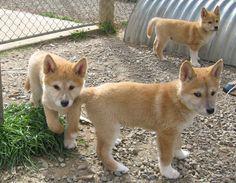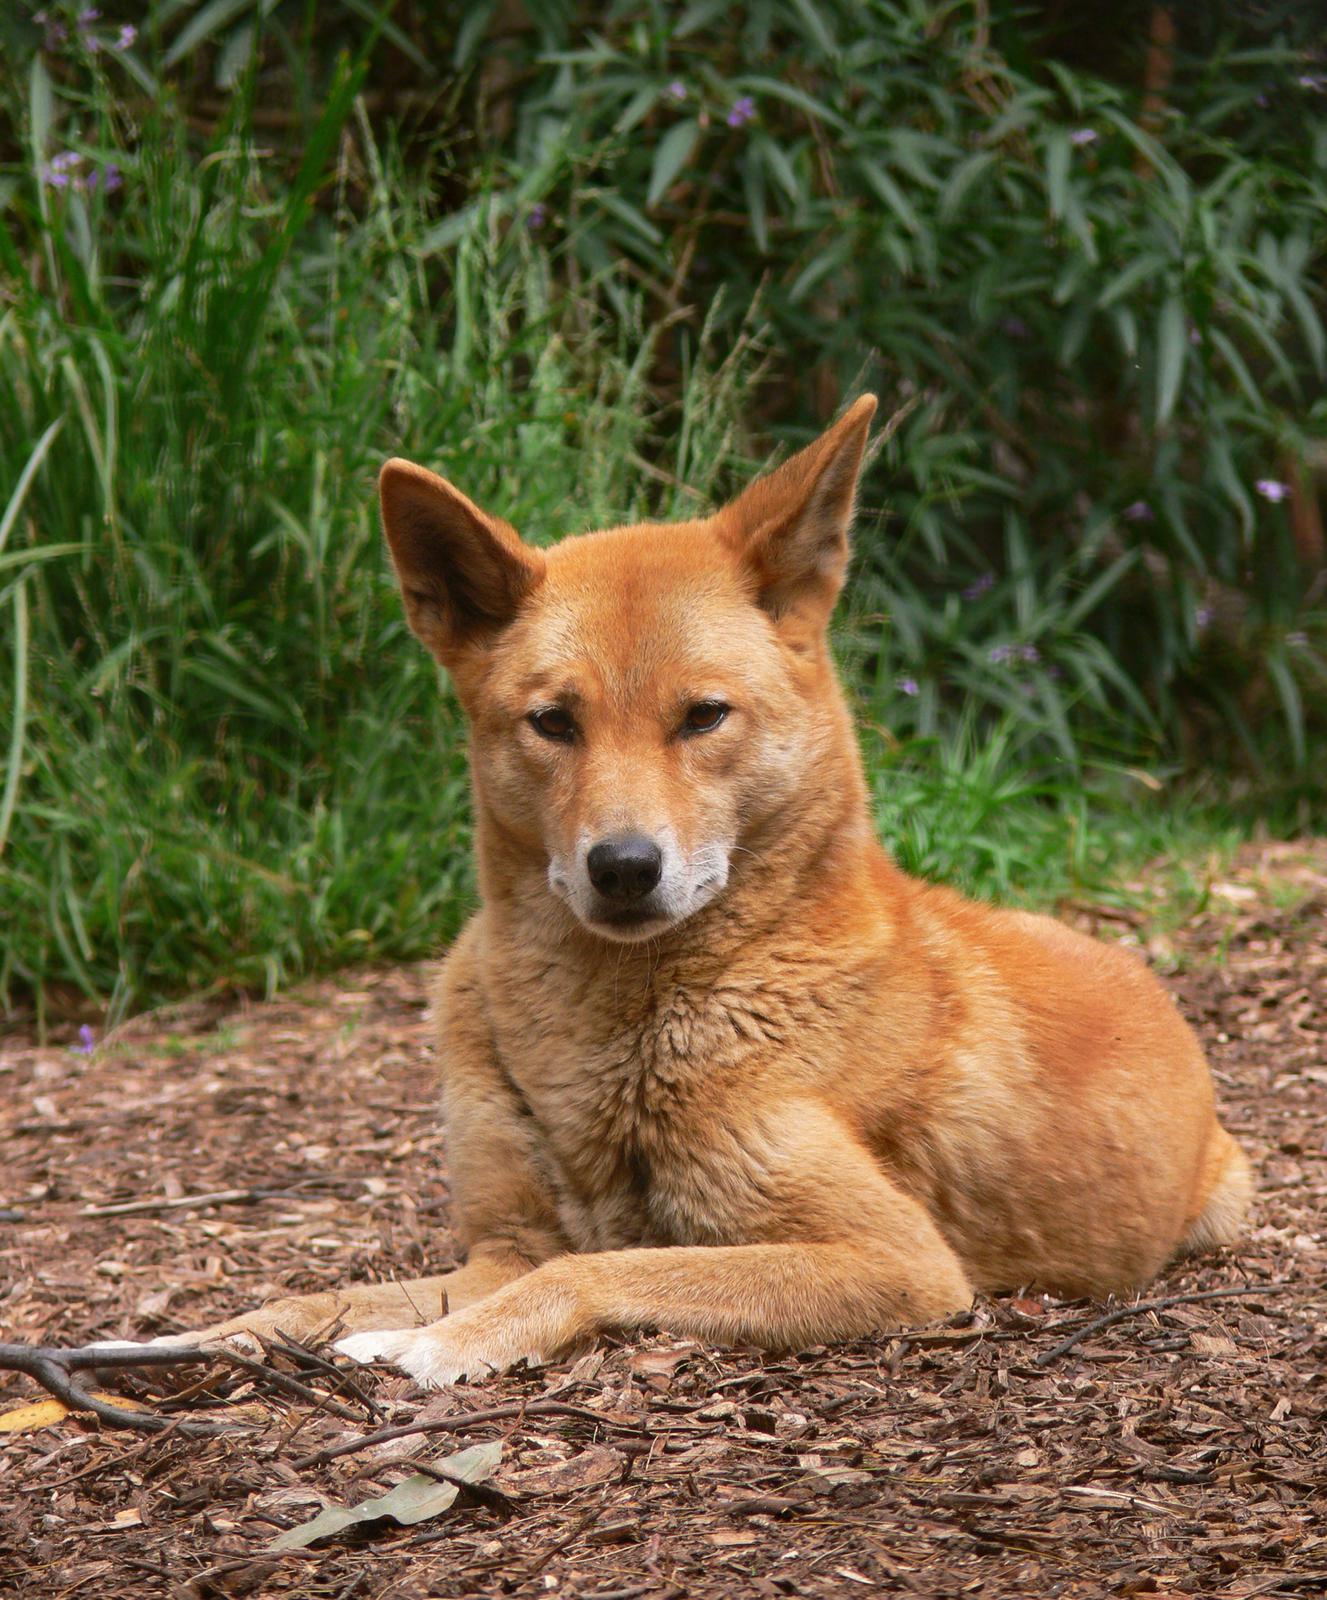The first image is the image on the left, the second image is the image on the right. Assess this claim about the two images: "The right image contains at least two dingoes.". Correct or not? Answer yes or no. No. The first image is the image on the left, the second image is the image on the right. Examine the images to the left and right. Is the description "There are at most 3 dingos in the image pair" accurate? Answer yes or no. No. 